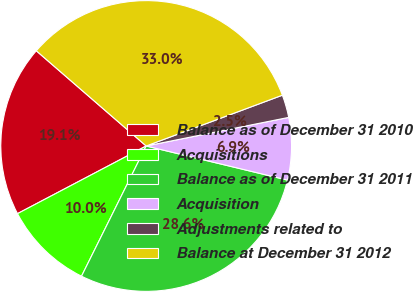Convert chart. <chart><loc_0><loc_0><loc_500><loc_500><pie_chart><fcel>Balance as of December 31 2010<fcel>Acquisitions<fcel>Balance as of December 31 2011<fcel>Acquisition<fcel>Adjustments related to<fcel>Balance at December 31 2012<nl><fcel>19.07%<fcel>9.96%<fcel>28.57%<fcel>6.92%<fcel>2.53%<fcel>32.96%<nl></chart> 